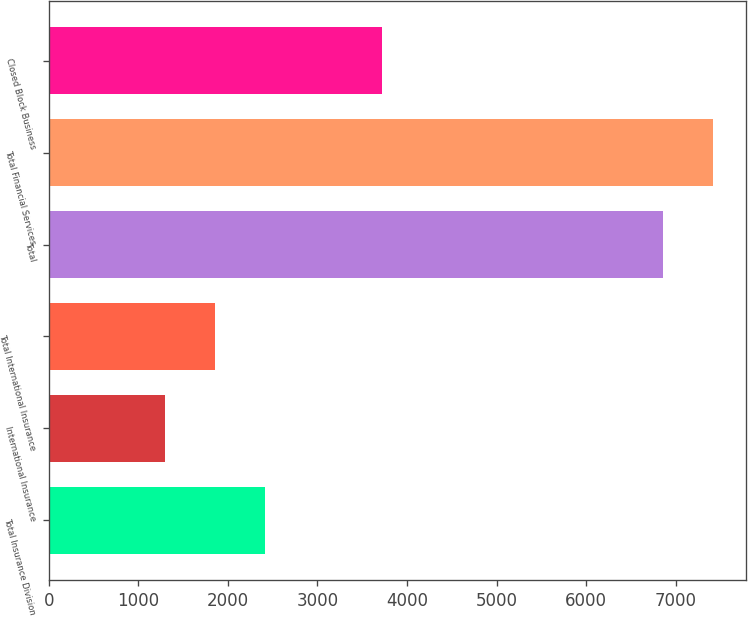<chart> <loc_0><loc_0><loc_500><loc_500><bar_chart><fcel>Total Insurance Division<fcel>International Insurance<fcel>Total International Insurance<fcel>Total<fcel>Total Financial Services<fcel>Closed Block Business<nl><fcel>2414<fcel>1299<fcel>1856.5<fcel>6861<fcel>7418.5<fcel>3721<nl></chart> 